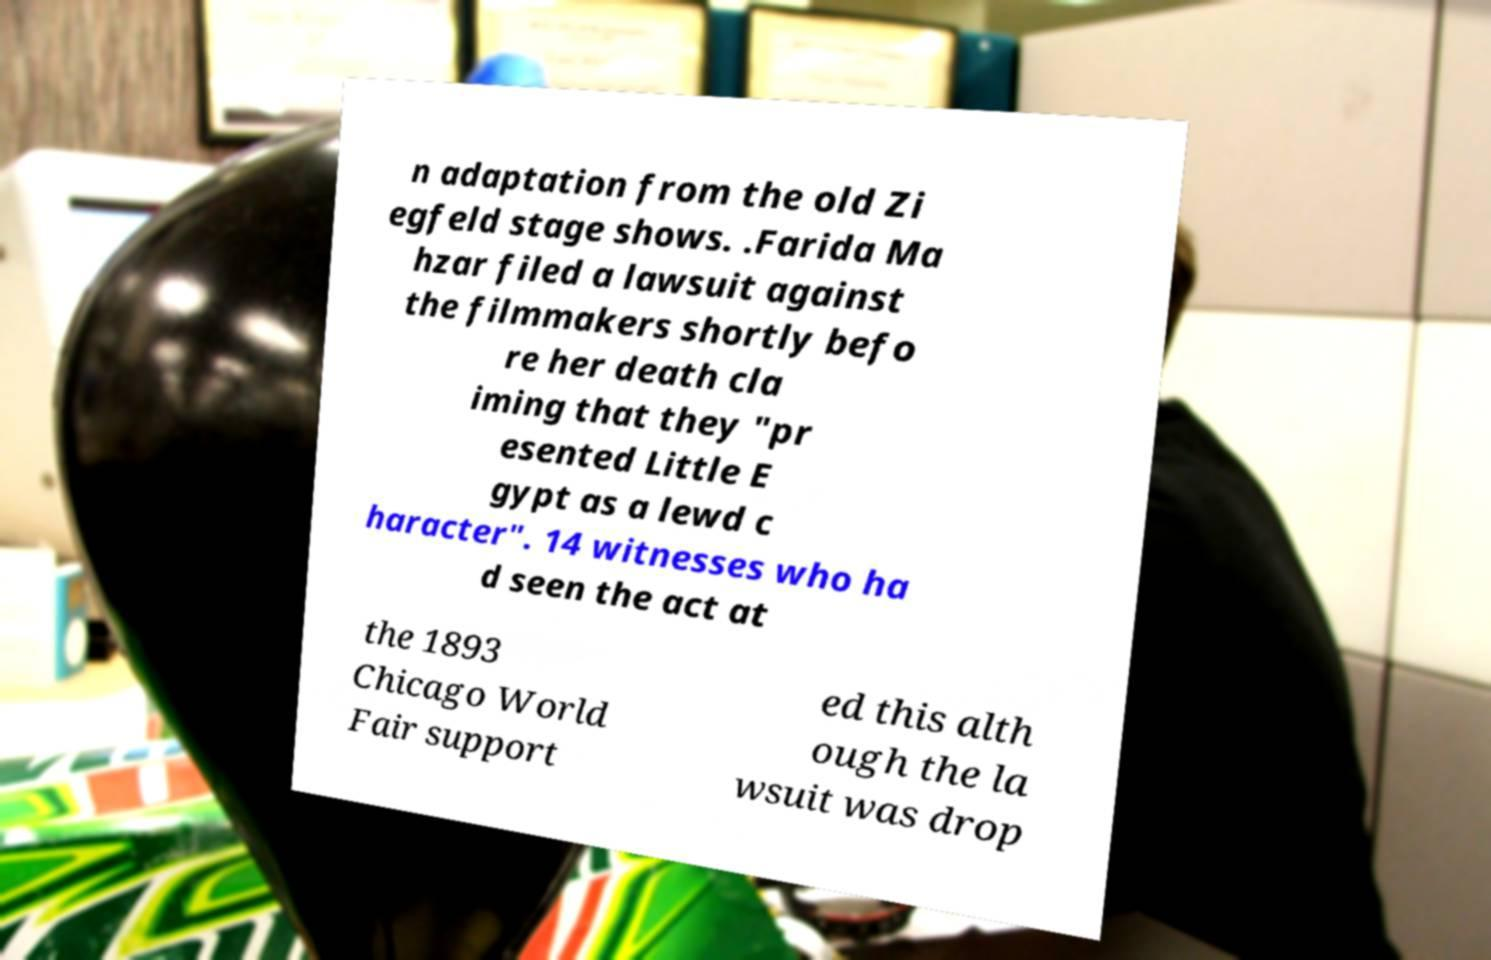Please read and relay the text visible in this image. What does it say? n adaptation from the old Zi egfeld stage shows. .Farida Ma hzar filed a lawsuit against the filmmakers shortly befo re her death cla iming that they "pr esented Little E gypt as a lewd c haracter". 14 witnesses who ha d seen the act at the 1893 Chicago World Fair support ed this alth ough the la wsuit was drop 